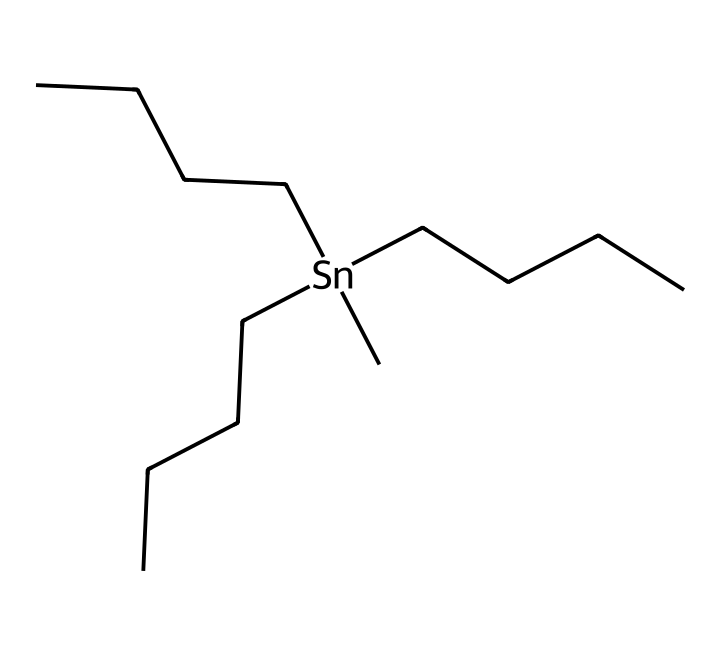What is the central atom in this chemical structure? The central atom can be identified as the one that is not part of a long carbon chain and is bonded to multiple carbon groups. In the provided SMILES, tin (Sn) is the central atom that is surrounded by three butyl groups.
Answer: tin How many butyl groups are attached to the central atom? In the SMILES representation, there are three instances of “CCCC” which indicate the butyl groups bonded to the tin atom. Each "CCCC" corresponds to one butyl group.
Answer: three What is the chemical class of this compound? This compound belongs to the class of coordination compounds in which a central atom (tin) is surrounded by ligands (the butyl groups). The multiple bonds around a metal make it a coordination compound rather than a simple organic molecule.
Answer: coordination compound What is the oxidation state of the central atom in this complex? To determine the oxidation state of tin (Sn) in this compound, we consider that butyl groups (which are neutral) do not contribute to the charge. Therefore, tin should have an oxidation state of +4 to balance out the four total bonds formed (making it tetracoordinate).
Answer: +4 How many total carbon atoms are present in the entire compound? Each butyl group has four carbon atoms, and since there are three butyl groups, the total count can be calculated as 3 groups × 4 carbons/group = 12 carbons.
Answer: 12 